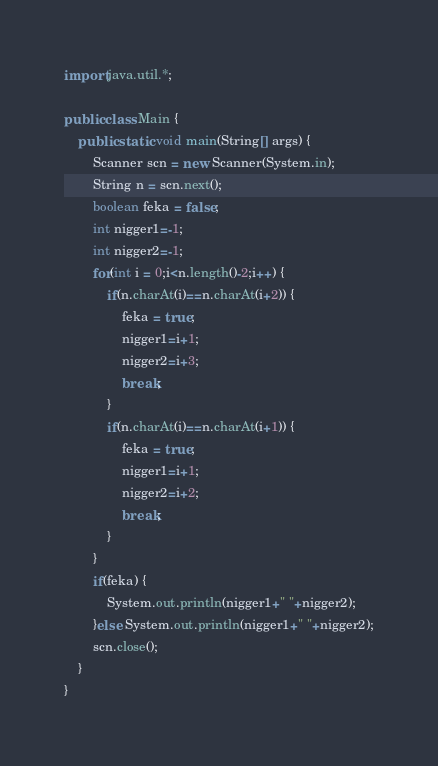<code> <loc_0><loc_0><loc_500><loc_500><_Java_>import java.util.*;

public class Main {
	public static void main(String[] args) {
		Scanner scn = new Scanner(System.in);
		String n = scn.next();
		boolean feka = false;
		int nigger1=-1;
		int nigger2=-1;
		for(int i = 0;i<n.length()-2;i++) {
			if(n.charAt(i)==n.charAt(i+2)) {
				feka = true;
				nigger1=i+1;
				nigger2=i+3;
				break;
			}
			if(n.charAt(i)==n.charAt(i+1)) {
				feka = true;
				nigger1=i+1;
				nigger2=i+2;
				break;
			}
		}
		if(feka) {
			System.out.println(nigger1+" "+nigger2);
		}else System.out.println(nigger1+" "+nigger2);
		scn.close();
	}
}</code> 